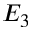Convert formula to latex. <formula><loc_0><loc_0><loc_500><loc_500>E _ { 3 }</formula> 